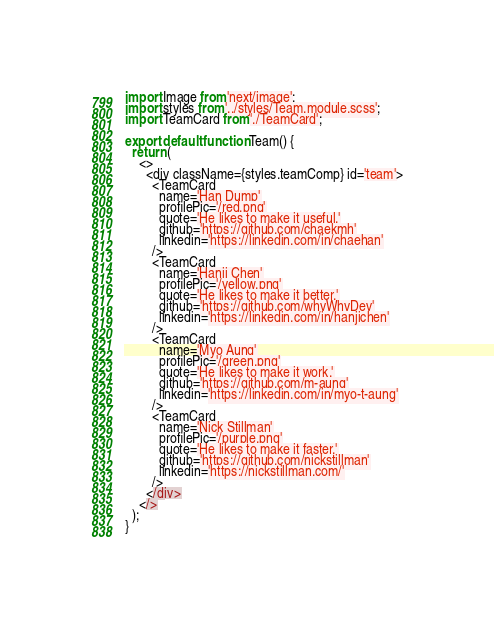Convert code to text. <code><loc_0><loc_0><loc_500><loc_500><_JavaScript_>import Image from 'next/image';
import styles from '../styles/Team.module.scss';
import TeamCard from './TeamCard';

export default function Team() {
  return (
    <>
      <div className={styles.teamComp} id='team'>
        <TeamCard
          name='Han Dump'
          profilePic='/red.png'
          quote='He likes to make it useful.'
          github='https://github.com/chaekmh'
          linkedin='https://linkedin.com/in/chaehan'
        />
        <TeamCard
          name='Hanji Chen'
          profilePic='/yellow.png'
          quote='He likes to make it better.'
          github='https://github.com/whyWhyDev'
          linkedin='https://linkedin.com/in/hanjichen'
        />
        <TeamCard
          name='Myo Aung'
          profilePic='/green.png'
          quote='He likes to make it work.'
          github='https://github.com/m-aung'
          linkedin='https://linkedin.com/in/myo-t-aung'
        />
        <TeamCard
          name='Nick Stillman'
          profilePic='/purple.png'
          quote='He likes to make it faster.'
          github='https://github.com/nickstillman'
          linkedin='https://nickstillman.com/'
        />
      </div>
    </>
  );
}
</code> 